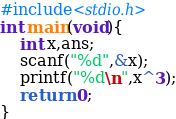<code> <loc_0><loc_0><loc_500><loc_500><_C_>#include<stdio.h>
int main(void){
    int x,ans;
    scanf("%d",&x);
    printf("%d\n",x^3);
    return 0;
}</code> 